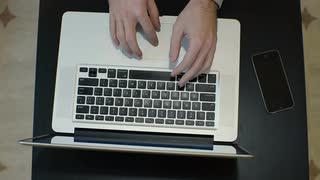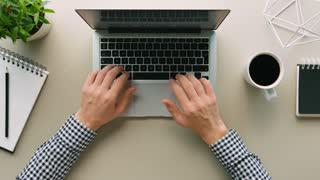The first image is the image on the left, the second image is the image on the right. For the images displayed, is the sentence "In each image, a person's hands are on a laptop keyboard that has black keys on an otherwise light-colored surface." factually correct? Answer yes or no. Yes. The first image is the image on the left, the second image is the image on the right. Evaluate the accuracy of this statement regarding the images: "Each image features a pair of hands over a keyboard, and the right image is an aerial view showing fingers over the black keyboard keys of one laptop.". Is it true? Answer yes or no. Yes. 